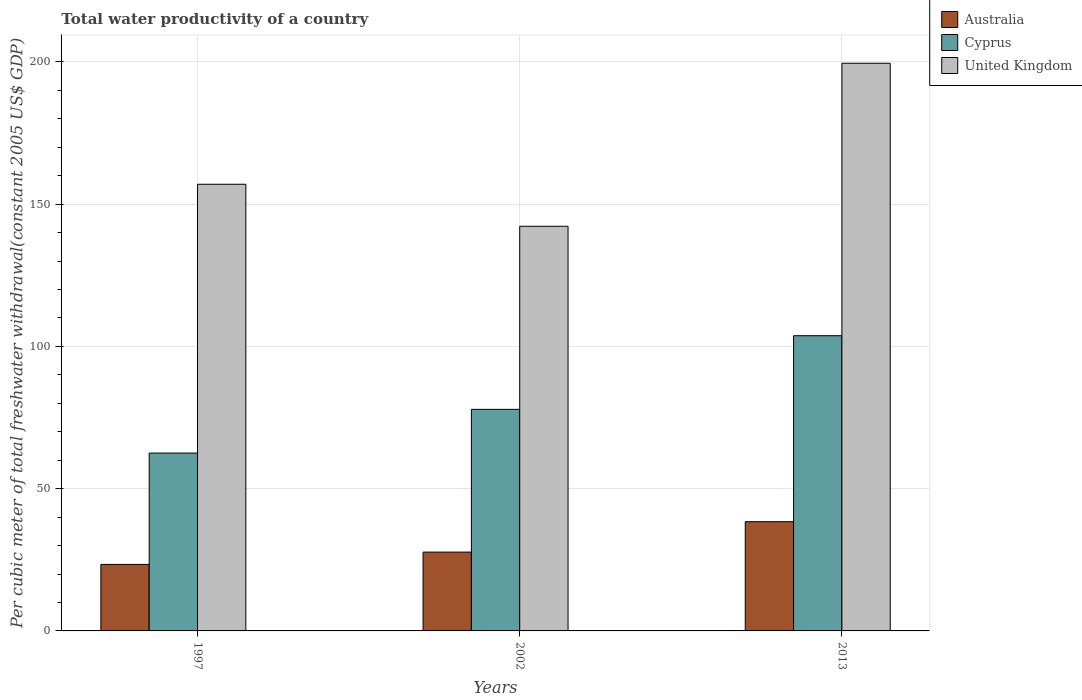How many groups of bars are there?
Make the answer very short. 3. Are the number of bars per tick equal to the number of legend labels?
Offer a very short reply. Yes. What is the label of the 3rd group of bars from the left?
Provide a succinct answer. 2013. In how many cases, is the number of bars for a given year not equal to the number of legend labels?
Offer a very short reply. 0. What is the total water productivity in Australia in 2013?
Your response must be concise. 38.4. Across all years, what is the maximum total water productivity in Cyprus?
Provide a succinct answer. 103.77. Across all years, what is the minimum total water productivity in United Kingdom?
Ensure brevity in your answer.  142.24. In which year was the total water productivity in Cyprus maximum?
Provide a short and direct response. 2013. What is the total total water productivity in Cyprus in the graph?
Make the answer very short. 244.17. What is the difference between the total water productivity in United Kingdom in 1997 and that in 2002?
Your response must be concise. 14.77. What is the difference between the total water productivity in Cyprus in 1997 and the total water productivity in United Kingdom in 2013?
Provide a short and direct response. -137.03. What is the average total water productivity in Australia per year?
Provide a succinct answer. 29.83. In the year 2013, what is the difference between the total water productivity in Australia and total water productivity in Cyprus?
Your response must be concise. -65.37. In how many years, is the total water productivity in United Kingdom greater than 100 US$?
Provide a succinct answer. 3. What is the ratio of the total water productivity in Australia in 2002 to that in 2013?
Your answer should be compact. 0.72. Is the total water productivity in Australia in 2002 less than that in 2013?
Keep it short and to the point. Yes. Is the difference between the total water productivity in Australia in 2002 and 2013 greater than the difference between the total water productivity in Cyprus in 2002 and 2013?
Give a very brief answer. Yes. What is the difference between the highest and the second highest total water productivity in Cyprus?
Provide a succinct answer. 25.88. What is the difference between the highest and the lowest total water productivity in United Kingdom?
Make the answer very short. 57.3. In how many years, is the total water productivity in United Kingdom greater than the average total water productivity in United Kingdom taken over all years?
Your response must be concise. 1. Is the sum of the total water productivity in Australia in 1997 and 2013 greater than the maximum total water productivity in Cyprus across all years?
Your answer should be compact. No. What does the 2nd bar from the left in 2002 represents?
Your response must be concise. Cyprus. What does the 2nd bar from the right in 2013 represents?
Your response must be concise. Cyprus. How many years are there in the graph?
Make the answer very short. 3. What is the difference between two consecutive major ticks on the Y-axis?
Your response must be concise. 50. Does the graph contain any zero values?
Your response must be concise. No. Does the graph contain grids?
Provide a short and direct response. Yes. How many legend labels are there?
Your answer should be very brief. 3. How are the legend labels stacked?
Your answer should be very brief. Vertical. What is the title of the graph?
Your response must be concise. Total water productivity of a country. Does "Sint Maarten (Dutch part)" appear as one of the legend labels in the graph?
Your answer should be very brief. No. What is the label or title of the X-axis?
Give a very brief answer. Years. What is the label or title of the Y-axis?
Ensure brevity in your answer.  Per cubic meter of total freshwater withdrawal(constant 2005 US$ GDP). What is the Per cubic meter of total freshwater withdrawal(constant 2005 US$ GDP) in Australia in 1997?
Make the answer very short. 23.38. What is the Per cubic meter of total freshwater withdrawal(constant 2005 US$ GDP) in Cyprus in 1997?
Your response must be concise. 62.52. What is the Per cubic meter of total freshwater withdrawal(constant 2005 US$ GDP) of United Kingdom in 1997?
Give a very brief answer. 157.01. What is the Per cubic meter of total freshwater withdrawal(constant 2005 US$ GDP) in Australia in 2002?
Offer a very short reply. 27.7. What is the Per cubic meter of total freshwater withdrawal(constant 2005 US$ GDP) of Cyprus in 2002?
Make the answer very short. 77.89. What is the Per cubic meter of total freshwater withdrawal(constant 2005 US$ GDP) in United Kingdom in 2002?
Your answer should be compact. 142.24. What is the Per cubic meter of total freshwater withdrawal(constant 2005 US$ GDP) of Australia in 2013?
Give a very brief answer. 38.4. What is the Per cubic meter of total freshwater withdrawal(constant 2005 US$ GDP) of Cyprus in 2013?
Your answer should be compact. 103.77. What is the Per cubic meter of total freshwater withdrawal(constant 2005 US$ GDP) of United Kingdom in 2013?
Ensure brevity in your answer.  199.54. Across all years, what is the maximum Per cubic meter of total freshwater withdrawal(constant 2005 US$ GDP) in Australia?
Your response must be concise. 38.4. Across all years, what is the maximum Per cubic meter of total freshwater withdrawal(constant 2005 US$ GDP) in Cyprus?
Your answer should be very brief. 103.77. Across all years, what is the maximum Per cubic meter of total freshwater withdrawal(constant 2005 US$ GDP) in United Kingdom?
Give a very brief answer. 199.54. Across all years, what is the minimum Per cubic meter of total freshwater withdrawal(constant 2005 US$ GDP) of Australia?
Ensure brevity in your answer.  23.38. Across all years, what is the minimum Per cubic meter of total freshwater withdrawal(constant 2005 US$ GDP) in Cyprus?
Keep it short and to the point. 62.52. Across all years, what is the minimum Per cubic meter of total freshwater withdrawal(constant 2005 US$ GDP) in United Kingdom?
Your answer should be compact. 142.24. What is the total Per cubic meter of total freshwater withdrawal(constant 2005 US$ GDP) in Australia in the graph?
Offer a very short reply. 89.48. What is the total Per cubic meter of total freshwater withdrawal(constant 2005 US$ GDP) of Cyprus in the graph?
Your response must be concise. 244.17. What is the total Per cubic meter of total freshwater withdrawal(constant 2005 US$ GDP) of United Kingdom in the graph?
Provide a short and direct response. 498.8. What is the difference between the Per cubic meter of total freshwater withdrawal(constant 2005 US$ GDP) of Australia in 1997 and that in 2002?
Give a very brief answer. -4.33. What is the difference between the Per cubic meter of total freshwater withdrawal(constant 2005 US$ GDP) in Cyprus in 1997 and that in 2002?
Provide a succinct answer. -15.37. What is the difference between the Per cubic meter of total freshwater withdrawal(constant 2005 US$ GDP) of United Kingdom in 1997 and that in 2002?
Give a very brief answer. 14.77. What is the difference between the Per cubic meter of total freshwater withdrawal(constant 2005 US$ GDP) of Australia in 1997 and that in 2013?
Your answer should be very brief. -15.02. What is the difference between the Per cubic meter of total freshwater withdrawal(constant 2005 US$ GDP) in Cyprus in 1997 and that in 2013?
Provide a short and direct response. -41.26. What is the difference between the Per cubic meter of total freshwater withdrawal(constant 2005 US$ GDP) of United Kingdom in 1997 and that in 2013?
Offer a very short reply. -42.53. What is the difference between the Per cubic meter of total freshwater withdrawal(constant 2005 US$ GDP) in Australia in 2002 and that in 2013?
Provide a short and direct response. -10.7. What is the difference between the Per cubic meter of total freshwater withdrawal(constant 2005 US$ GDP) in Cyprus in 2002 and that in 2013?
Make the answer very short. -25.88. What is the difference between the Per cubic meter of total freshwater withdrawal(constant 2005 US$ GDP) in United Kingdom in 2002 and that in 2013?
Your response must be concise. -57.3. What is the difference between the Per cubic meter of total freshwater withdrawal(constant 2005 US$ GDP) of Australia in 1997 and the Per cubic meter of total freshwater withdrawal(constant 2005 US$ GDP) of Cyprus in 2002?
Make the answer very short. -54.51. What is the difference between the Per cubic meter of total freshwater withdrawal(constant 2005 US$ GDP) in Australia in 1997 and the Per cubic meter of total freshwater withdrawal(constant 2005 US$ GDP) in United Kingdom in 2002?
Provide a succinct answer. -118.86. What is the difference between the Per cubic meter of total freshwater withdrawal(constant 2005 US$ GDP) of Cyprus in 1997 and the Per cubic meter of total freshwater withdrawal(constant 2005 US$ GDP) of United Kingdom in 2002?
Your response must be concise. -79.73. What is the difference between the Per cubic meter of total freshwater withdrawal(constant 2005 US$ GDP) of Australia in 1997 and the Per cubic meter of total freshwater withdrawal(constant 2005 US$ GDP) of Cyprus in 2013?
Provide a short and direct response. -80.39. What is the difference between the Per cubic meter of total freshwater withdrawal(constant 2005 US$ GDP) of Australia in 1997 and the Per cubic meter of total freshwater withdrawal(constant 2005 US$ GDP) of United Kingdom in 2013?
Provide a succinct answer. -176.17. What is the difference between the Per cubic meter of total freshwater withdrawal(constant 2005 US$ GDP) in Cyprus in 1997 and the Per cubic meter of total freshwater withdrawal(constant 2005 US$ GDP) in United Kingdom in 2013?
Your answer should be compact. -137.03. What is the difference between the Per cubic meter of total freshwater withdrawal(constant 2005 US$ GDP) of Australia in 2002 and the Per cubic meter of total freshwater withdrawal(constant 2005 US$ GDP) of Cyprus in 2013?
Your answer should be very brief. -76.07. What is the difference between the Per cubic meter of total freshwater withdrawal(constant 2005 US$ GDP) in Australia in 2002 and the Per cubic meter of total freshwater withdrawal(constant 2005 US$ GDP) in United Kingdom in 2013?
Provide a short and direct response. -171.84. What is the difference between the Per cubic meter of total freshwater withdrawal(constant 2005 US$ GDP) in Cyprus in 2002 and the Per cubic meter of total freshwater withdrawal(constant 2005 US$ GDP) in United Kingdom in 2013?
Your answer should be very brief. -121.66. What is the average Per cubic meter of total freshwater withdrawal(constant 2005 US$ GDP) of Australia per year?
Provide a short and direct response. 29.83. What is the average Per cubic meter of total freshwater withdrawal(constant 2005 US$ GDP) in Cyprus per year?
Make the answer very short. 81.39. What is the average Per cubic meter of total freshwater withdrawal(constant 2005 US$ GDP) in United Kingdom per year?
Your response must be concise. 166.27. In the year 1997, what is the difference between the Per cubic meter of total freshwater withdrawal(constant 2005 US$ GDP) of Australia and Per cubic meter of total freshwater withdrawal(constant 2005 US$ GDP) of Cyprus?
Your response must be concise. -39.14. In the year 1997, what is the difference between the Per cubic meter of total freshwater withdrawal(constant 2005 US$ GDP) in Australia and Per cubic meter of total freshwater withdrawal(constant 2005 US$ GDP) in United Kingdom?
Your answer should be compact. -133.63. In the year 1997, what is the difference between the Per cubic meter of total freshwater withdrawal(constant 2005 US$ GDP) in Cyprus and Per cubic meter of total freshwater withdrawal(constant 2005 US$ GDP) in United Kingdom?
Give a very brief answer. -94.5. In the year 2002, what is the difference between the Per cubic meter of total freshwater withdrawal(constant 2005 US$ GDP) of Australia and Per cubic meter of total freshwater withdrawal(constant 2005 US$ GDP) of Cyprus?
Offer a terse response. -50.18. In the year 2002, what is the difference between the Per cubic meter of total freshwater withdrawal(constant 2005 US$ GDP) of Australia and Per cubic meter of total freshwater withdrawal(constant 2005 US$ GDP) of United Kingdom?
Offer a very short reply. -114.54. In the year 2002, what is the difference between the Per cubic meter of total freshwater withdrawal(constant 2005 US$ GDP) in Cyprus and Per cubic meter of total freshwater withdrawal(constant 2005 US$ GDP) in United Kingdom?
Provide a short and direct response. -64.35. In the year 2013, what is the difference between the Per cubic meter of total freshwater withdrawal(constant 2005 US$ GDP) in Australia and Per cubic meter of total freshwater withdrawal(constant 2005 US$ GDP) in Cyprus?
Offer a very short reply. -65.37. In the year 2013, what is the difference between the Per cubic meter of total freshwater withdrawal(constant 2005 US$ GDP) of Australia and Per cubic meter of total freshwater withdrawal(constant 2005 US$ GDP) of United Kingdom?
Your response must be concise. -161.14. In the year 2013, what is the difference between the Per cubic meter of total freshwater withdrawal(constant 2005 US$ GDP) in Cyprus and Per cubic meter of total freshwater withdrawal(constant 2005 US$ GDP) in United Kingdom?
Make the answer very short. -95.77. What is the ratio of the Per cubic meter of total freshwater withdrawal(constant 2005 US$ GDP) of Australia in 1997 to that in 2002?
Your response must be concise. 0.84. What is the ratio of the Per cubic meter of total freshwater withdrawal(constant 2005 US$ GDP) of Cyprus in 1997 to that in 2002?
Make the answer very short. 0.8. What is the ratio of the Per cubic meter of total freshwater withdrawal(constant 2005 US$ GDP) of United Kingdom in 1997 to that in 2002?
Your response must be concise. 1.1. What is the ratio of the Per cubic meter of total freshwater withdrawal(constant 2005 US$ GDP) of Australia in 1997 to that in 2013?
Keep it short and to the point. 0.61. What is the ratio of the Per cubic meter of total freshwater withdrawal(constant 2005 US$ GDP) in Cyprus in 1997 to that in 2013?
Keep it short and to the point. 0.6. What is the ratio of the Per cubic meter of total freshwater withdrawal(constant 2005 US$ GDP) of United Kingdom in 1997 to that in 2013?
Provide a succinct answer. 0.79. What is the ratio of the Per cubic meter of total freshwater withdrawal(constant 2005 US$ GDP) in Australia in 2002 to that in 2013?
Keep it short and to the point. 0.72. What is the ratio of the Per cubic meter of total freshwater withdrawal(constant 2005 US$ GDP) of Cyprus in 2002 to that in 2013?
Provide a succinct answer. 0.75. What is the ratio of the Per cubic meter of total freshwater withdrawal(constant 2005 US$ GDP) in United Kingdom in 2002 to that in 2013?
Your response must be concise. 0.71. What is the difference between the highest and the second highest Per cubic meter of total freshwater withdrawal(constant 2005 US$ GDP) in Australia?
Provide a succinct answer. 10.7. What is the difference between the highest and the second highest Per cubic meter of total freshwater withdrawal(constant 2005 US$ GDP) in Cyprus?
Your response must be concise. 25.88. What is the difference between the highest and the second highest Per cubic meter of total freshwater withdrawal(constant 2005 US$ GDP) in United Kingdom?
Give a very brief answer. 42.53. What is the difference between the highest and the lowest Per cubic meter of total freshwater withdrawal(constant 2005 US$ GDP) of Australia?
Your answer should be compact. 15.02. What is the difference between the highest and the lowest Per cubic meter of total freshwater withdrawal(constant 2005 US$ GDP) of Cyprus?
Ensure brevity in your answer.  41.26. What is the difference between the highest and the lowest Per cubic meter of total freshwater withdrawal(constant 2005 US$ GDP) in United Kingdom?
Ensure brevity in your answer.  57.3. 